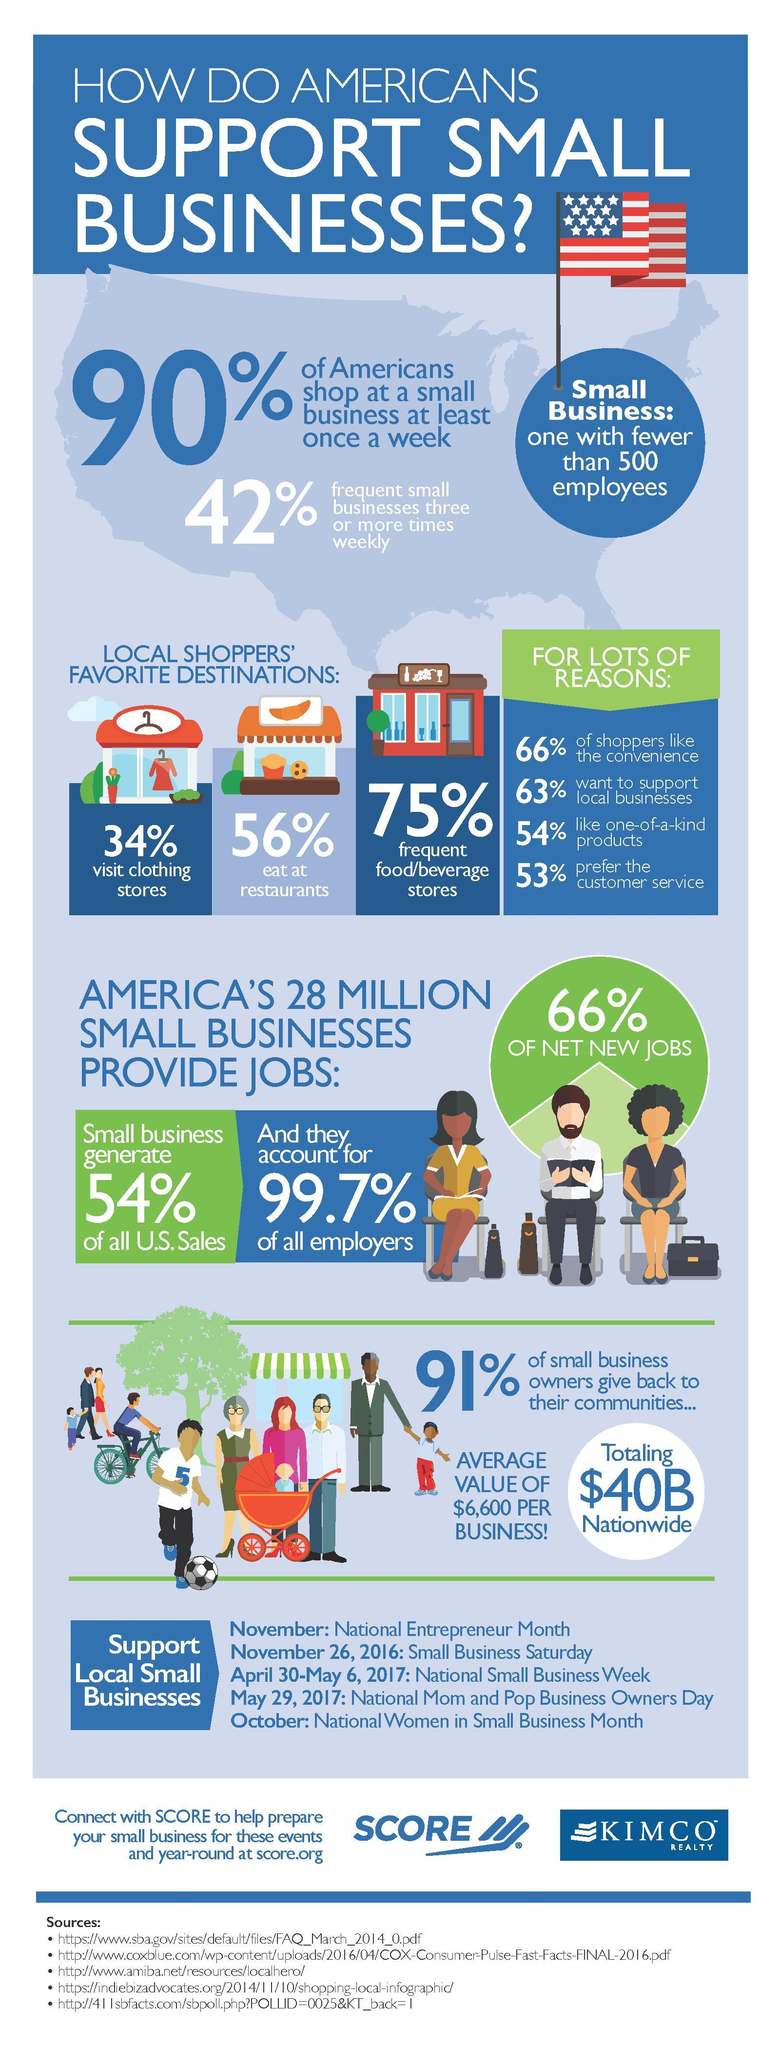What percentage of the total jobs available in America are owned by small businesses?
Answer the question with a short phrase. 99.7% What percentage of Americans do not like to eat at restaurants? 44 What percentage of Americans visits food.beverage shops often? 75% What percentage of money earned through small businesses is not going back for the welfare of society? 9 What percentage of U.S people loves to do shopping in local places? 34% What percentage of Americans love to buy only specific items? 54% What percentage of Americans shoppers do not bother about the convenience for shopping? 34 What percentage of the people of U.S do not purchase at all from small shops in a week? 10 What percentage of money earned through small businesses is going back for the welfare of society? 91% What is the inverse of the percentage of Americans who want to support local businesses? 37 